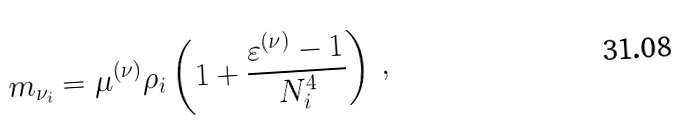Convert formula to latex. <formula><loc_0><loc_0><loc_500><loc_500>m _ { \nu _ { i } } = \mu ^ { ( \nu ) } \rho _ { i } \left ( 1 + \frac { \varepsilon ^ { ( \nu ) } - 1 } { N ^ { 4 } _ { i } } \right ) \, ,</formula> 